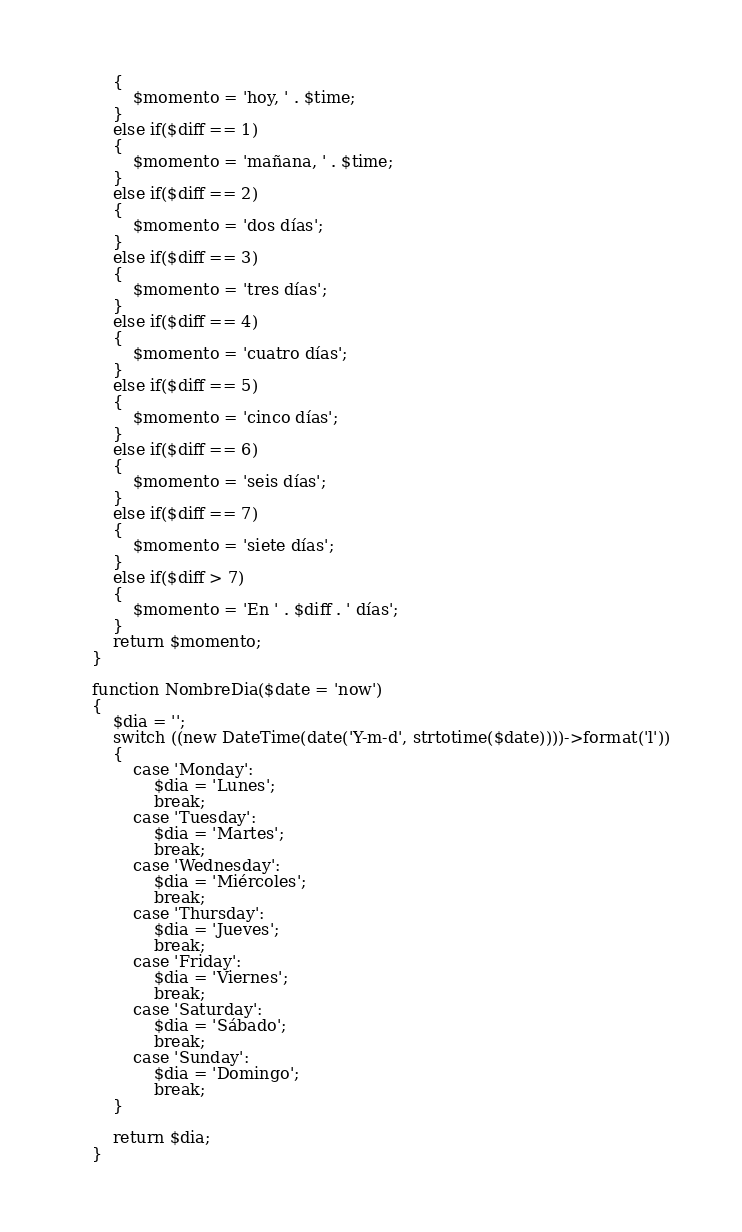Convert code to text. <code><loc_0><loc_0><loc_500><loc_500><_PHP_>        {
            $momento = 'hoy, ' . $time;
        }
        else if($diff == 1)
        {
            $momento = 'mañana, ' . $time;
        }
        else if($diff == 2)
        {
            $momento = 'dos días';
        }
        else if($diff == 3)
        {
            $momento = 'tres días';
        }
        else if($diff == 4)
        {
            $momento = 'cuatro días';
        }
        else if($diff == 5)
        {
            $momento = 'cinco días';
        }
        else if($diff == 6)
        {
            $momento = 'seis días';
        }
        else if($diff == 7)
        {
            $momento = 'siete días';
        }
        else if($diff > 7)
        {
            $momento = 'En ' . $diff . ' días';
        }
        return $momento;
    }

    function NombreDia($date = 'now')
    {
        $dia = '';
        switch ((new DateTime(date('Y-m-d', strtotime($date))))->format('l'))
        {
            case 'Monday':
                $dia = 'Lunes';
                break;
            case 'Tuesday':
                $dia = 'Martes';
                break;
            case 'Wednesday':
                $dia = 'Miércoles';
                break;
            case 'Thursday':
                $dia = 'Jueves';
                break;
            case 'Friday':
                $dia = 'Viernes';
                break;
            case 'Saturday':
                $dia = 'Sábado';
                break;
            case 'Sunday':
                $dia = 'Domingo';
                break;
        }

        return $dia;
    }</code> 